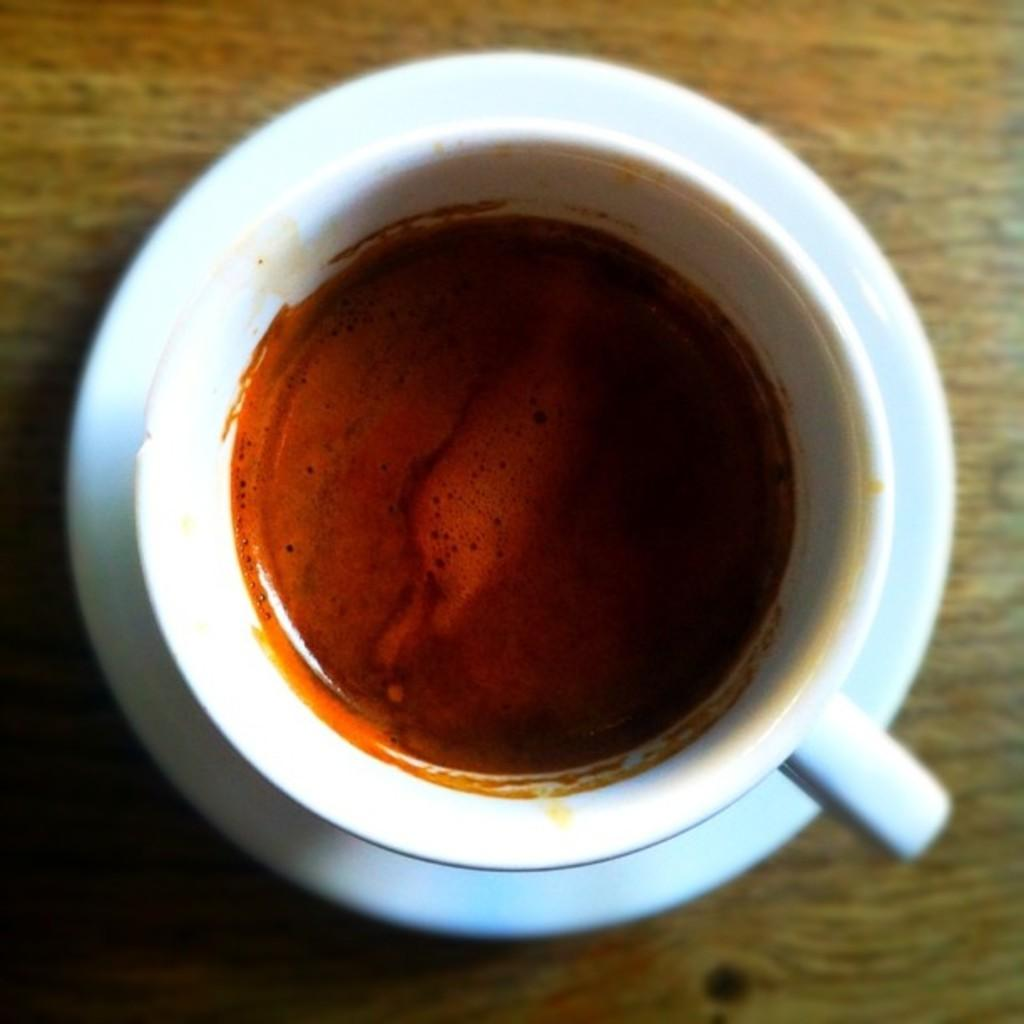Where was the image taken? The image is taken indoors. What piece of furniture is present in the image? There is a table in the image. What is placed on the table? There is a saucer and a cup with coffee on the table. Can you tell me how tall the wall is in the image? There is no wall present in the image; it is taken indoors, but the specific location or structure of the room is not visible. 